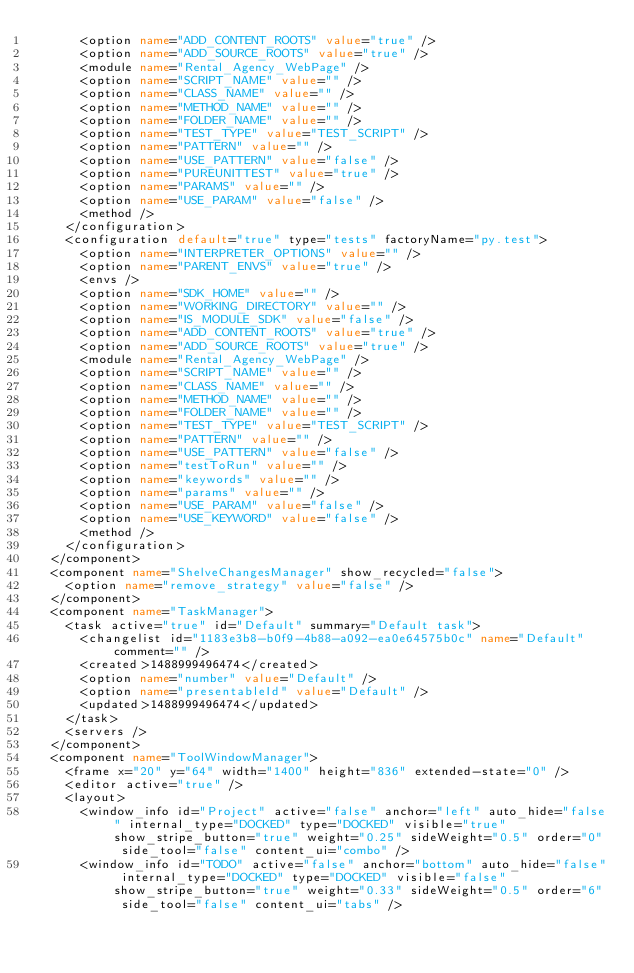<code> <loc_0><loc_0><loc_500><loc_500><_XML_>      <option name="ADD_CONTENT_ROOTS" value="true" />
      <option name="ADD_SOURCE_ROOTS" value="true" />
      <module name="Rental_Agency_WebPage" />
      <option name="SCRIPT_NAME" value="" />
      <option name="CLASS_NAME" value="" />
      <option name="METHOD_NAME" value="" />
      <option name="FOLDER_NAME" value="" />
      <option name="TEST_TYPE" value="TEST_SCRIPT" />
      <option name="PATTERN" value="" />
      <option name="USE_PATTERN" value="false" />
      <option name="PUREUNITTEST" value="true" />
      <option name="PARAMS" value="" />
      <option name="USE_PARAM" value="false" />
      <method />
    </configuration>
    <configuration default="true" type="tests" factoryName="py.test">
      <option name="INTERPRETER_OPTIONS" value="" />
      <option name="PARENT_ENVS" value="true" />
      <envs />
      <option name="SDK_HOME" value="" />
      <option name="WORKING_DIRECTORY" value="" />
      <option name="IS_MODULE_SDK" value="false" />
      <option name="ADD_CONTENT_ROOTS" value="true" />
      <option name="ADD_SOURCE_ROOTS" value="true" />
      <module name="Rental_Agency_WebPage" />
      <option name="SCRIPT_NAME" value="" />
      <option name="CLASS_NAME" value="" />
      <option name="METHOD_NAME" value="" />
      <option name="FOLDER_NAME" value="" />
      <option name="TEST_TYPE" value="TEST_SCRIPT" />
      <option name="PATTERN" value="" />
      <option name="USE_PATTERN" value="false" />
      <option name="testToRun" value="" />
      <option name="keywords" value="" />
      <option name="params" value="" />
      <option name="USE_PARAM" value="false" />
      <option name="USE_KEYWORD" value="false" />
      <method />
    </configuration>
  </component>
  <component name="ShelveChangesManager" show_recycled="false">
    <option name="remove_strategy" value="false" />
  </component>
  <component name="TaskManager">
    <task active="true" id="Default" summary="Default task">
      <changelist id="1183e3b8-b0f9-4b88-a092-ea0e64575b0c" name="Default" comment="" />
      <created>1488999496474</created>
      <option name="number" value="Default" />
      <option name="presentableId" value="Default" />
      <updated>1488999496474</updated>
    </task>
    <servers />
  </component>
  <component name="ToolWindowManager">
    <frame x="20" y="64" width="1400" height="836" extended-state="0" />
    <editor active="true" />
    <layout>
      <window_info id="Project" active="false" anchor="left" auto_hide="false" internal_type="DOCKED" type="DOCKED" visible="true" show_stripe_button="true" weight="0.25" sideWeight="0.5" order="0" side_tool="false" content_ui="combo" />
      <window_info id="TODO" active="false" anchor="bottom" auto_hide="false" internal_type="DOCKED" type="DOCKED" visible="false" show_stripe_button="true" weight="0.33" sideWeight="0.5" order="6" side_tool="false" content_ui="tabs" /></code> 